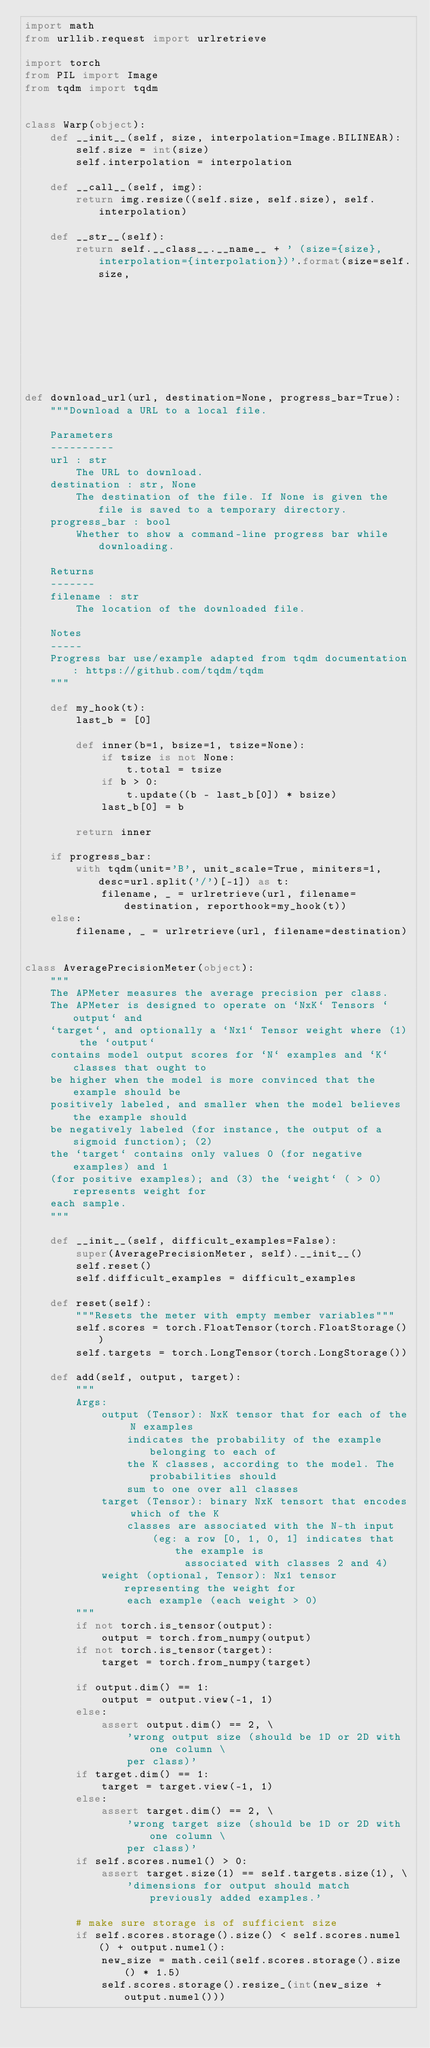<code> <loc_0><loc_0><loc_500><loc_500><_Python_>import math
from urllib.request import urlretrieve

import torch
from PIL import Image
from tqdm import tqdm


class Warp(object):
    def __init__(self, size, interpolation=Image.BILINEAR):
        self.size = int(size)
        self.interpolation = interpolation

    def __call__(self, img):
        return img.resize((self.size, self.size), self.interpolation)

    def __str__(self):
        return self.__class__.__name__ + ' (size={size}, interpolation={interpolation})'.format(size=self.size,
                                                                                                interpolation=self.interpolation)


def download_url(url, destination=None, progress_bar=True):
    """Download a URL to a local file.

    Parameters
    ----------
    url : str
        The URL to download.
    destination : str, None
        The destination of the file. If None is given the file is saved to a temporary directory.
    progress_bar : bool
        Whether to show a command-line progress bar while downloading.

    Returns
    -------
    filename : str
        The location of the downloaded file.

    Notes
    -----
    Progress bar use/example adapted from tqdm documentation: https://github.com/tqdm/tqdm
    """

    def my_hook(t):
        last_b = [0]

        def inner(b=1, bsize=1, tsize=None):
            if tsize is not None:
                t.total = tsize
            if b > 0:
                t.update((b - last_b[0]) * bsize)
            last_b[0] = b

        return inner

    if progress_bar:
        with tqdm(unit='B', unit_scale=True, miniters=1, desc=url.split('/')[-1]) as t:
            filename, _ = urlretrieve(url, filename=destination, reporthook=my_hook(t))
    else:
        filename, _ = urlretrieve(url, filename=destination)


class AveragePrecisionMeter(object):
    """
    The APMeter measures the average precision per class.
    The APMeter is designed to operate on `NxK` Tensors `output` and
    `target`, and optionally a `Nx1` Tensor weight where (1) the `output`
    contains model output scores for `N` examples and `K` classes that ought to
    be higher when the model is more convinced that the example should be
    positively labeled, and smaller when the model believes the example should
    be negatively labeled (for instance, the output of a sigmoid function); (2)
    the `target` contains only values 0 (for negative examples) and 1
    (for positive examples); and (3) the `weight` ( > 0) represents weight for
    each sample.
    """

    def __init__(self, difficult_examples=False):
        super(AveragePrecisionMeter, self).__init__()
        self.reset()
        self.difficult_examples = difficult_examples

    def reset(self):
        """Resets the meter with empty member variables"""
        self.scores = torch.FloatTensor(torch.FloatStorage())
        self.targets = torch.LongTensor(torch.LongStorage())

    def add(self, output, target):
        """
        Args:
            output (Tensor): NxK tensor that for each of the N examples
                indicates the probability of the example belonging to each of
                the K classes, according to the model. The probabilities should
                sum to one over all classes
            target (Tensor): binary NxK tensort that encodes which of the K
                classes are associated with the N-th input
                    (eg: a row [0, 1, 0, 1] indicates that the example is
                         associated with classes 2 and 4)
            weight (optional, Tensor): Nx1 tensor representing the weight for
                each example (each weight > 0)
        """
        if not torch.is_tensor(output):
            output = torch.from_numpy(output)
        if not torch.is_tensor(target):
            target = torch.from_numpy(target)

        if output.dim() == 1:
            output = output.view(-1, 1)
        else:
            assert output.dim() == 2, \
                'wrong output size (should be 1D or 2D with one column \
                per class)'
        if target.dim() == 1:
            target = target.view(-1, 1)
        else:
            assert target.dim() == 2, \
                'wrong target size (should be 1D or 2D with one column \
                per class)'
        if self.scores.numel() > 0:
            assert target.size(1) == self.targets.size(1), \
                'dimensions for output should match previously added examples.'

        # make sure storage is of sufficient size
        if self.scores.storage().size() < self.scores.numel() + output.numel():
            new_size = math.ceil(self.scores.storage().size() * 1.5)
            self.scores.storage().resize_(int(new_size + output.numel()))</code> 